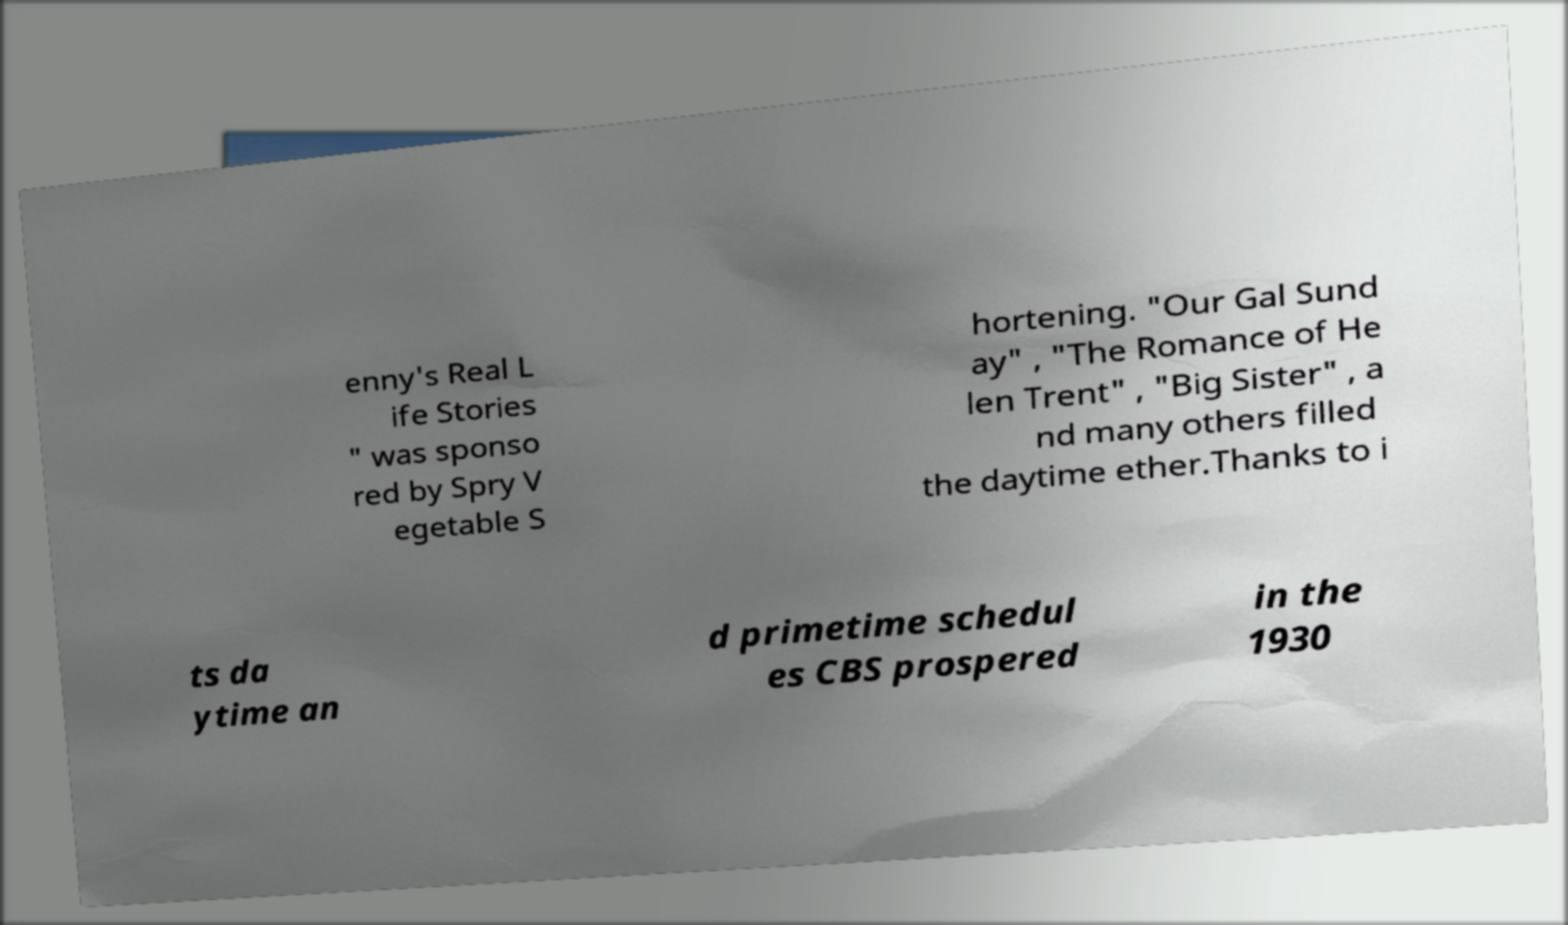There's text embedded in this image that I need extracted. Can you transcribe it verbatim? enny's Real L ife Stories " was sponso red by Spry V egetable S hortening. "Our Gal Sund ay" , "The Romance of He len Trent" , "Big Sister" , a nd many others filled the daytime ether.Thanks to i ts da ytime an d primetime schedul es CBS prospered in the 1930 